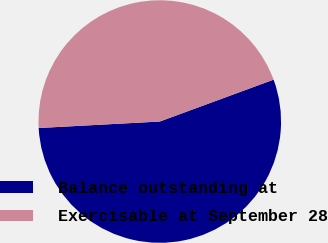Convert chart. <chart><loc_0><loc_0><loc_500><loc_500><pie_chart><fcel>Balance outstanding at<fcel>Exercisable at September 28<nl><fcel>54.76%<fcel>45.24%<nl></chart> 